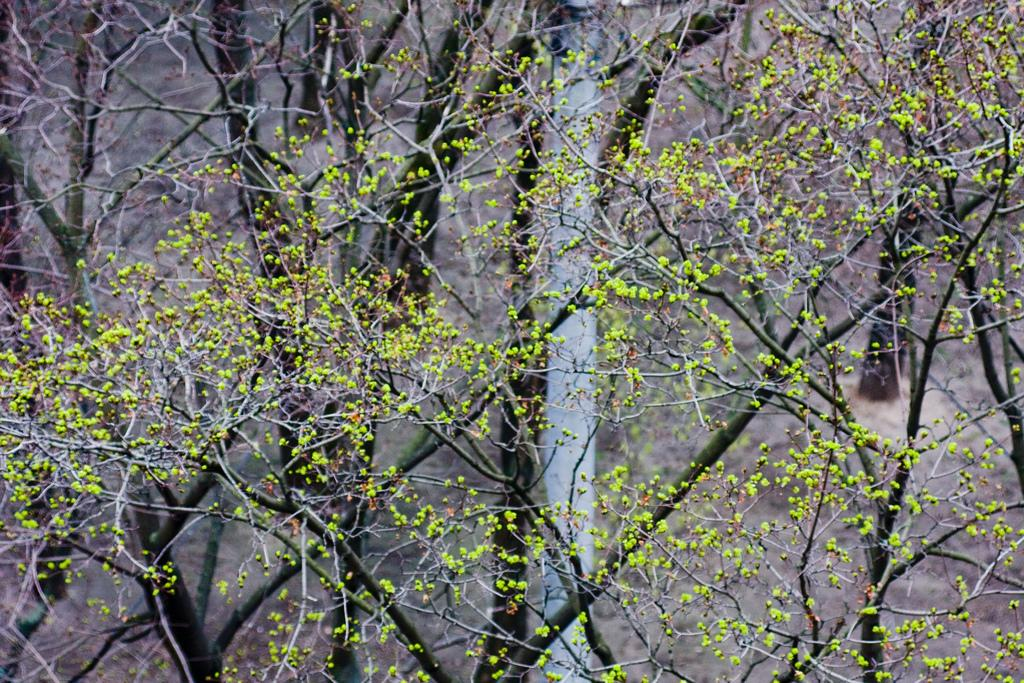What type of vegetation can be seen in the image? There are trees in the image. What part of the natural environment is visible in the image? The ground is visible in the background of the image. What advertisement can be seen on the trees in the image? There is no advertisement present on the trees in the image; only trees and the ground are visible. 